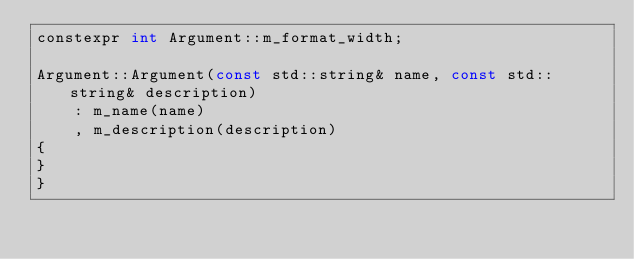<code> <loc_0><loc_0><loc_500><loc_500><_C++_>constexpr int Argument::m_format_width;

Argument::Argument(const std::string& name, const std::string& description)
    : m_name(name)
    , m_description(description)
{
}
}
</code> 